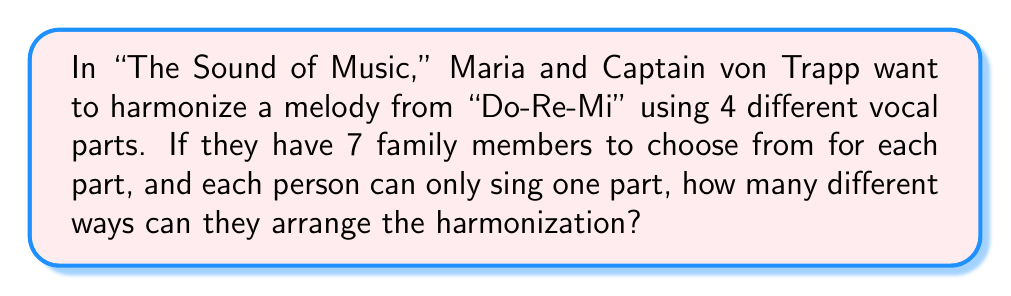Provide a solution to this math problem. Let's approach this step-by-step:

1) We need to select 4 people out of 7 for the 4 vocal parts.

2) This is a permutation problem because the order matters (each vocal part is distinct).

3) We can use the permutation formula:
   $P(n,r) = \frac{n!}{(n-r)!}$
   where $n$ is the total number of people and $r$ is the number of positions to be filled.

4) In this case, $n = 7$ and $r = 4$

5) Plugging these values into the formula:

   $P(7,4) = \frac{7!}{(7-4)!} = \frac{7!}{3!}$

6) Expanding this:
   $$\frac{7 * 6 * 5 * 4 * 3!}{3!}$$

7) The $3!$ cancels out in the numerator and denominator:
   $$7 * 6 * 5 * 4 = 840$$

Therefore, there are 840 different ways to arrange the harmonization.
Answer: 840 